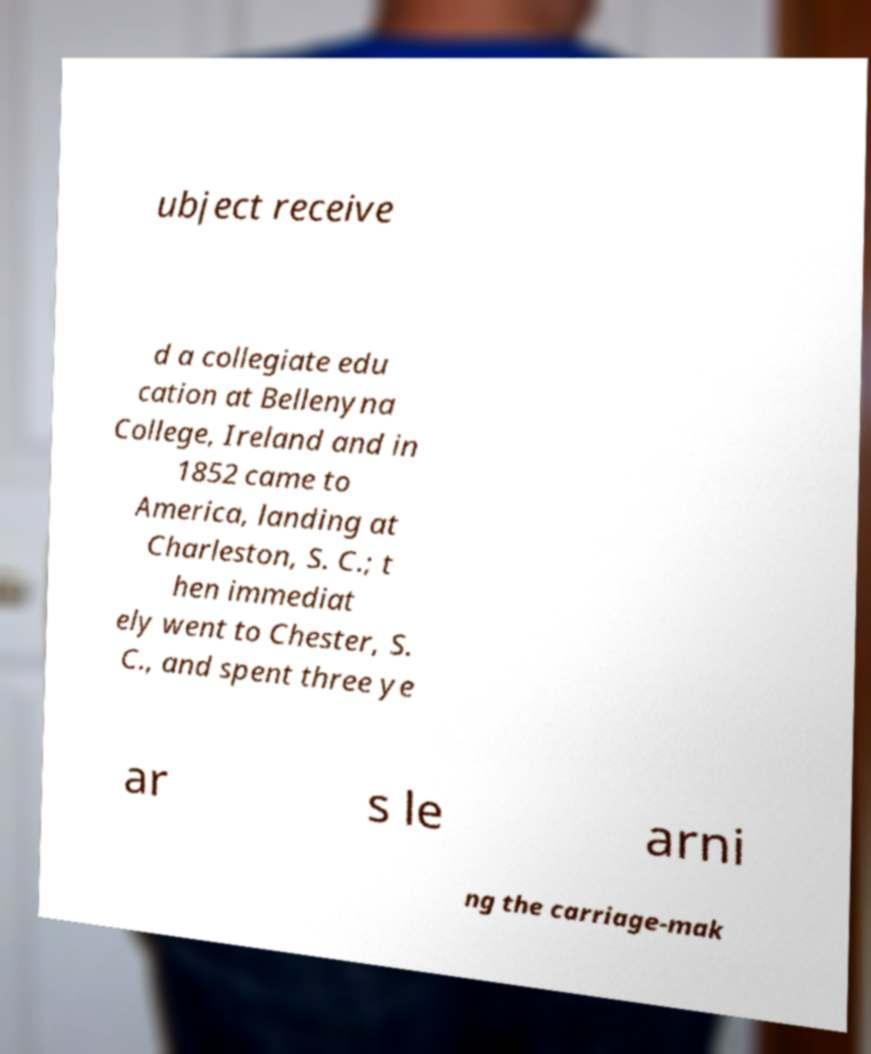Please identify and transcribe the text found in this image. ubject receive d a collegiate edu cation at Bellenyna College, Ireland and in 1852 came to America, landing at Charleston, S. C.; t hen immediat ely went to Chester, S. C., and spent three ye ar s le arni ng the carriage-mak 